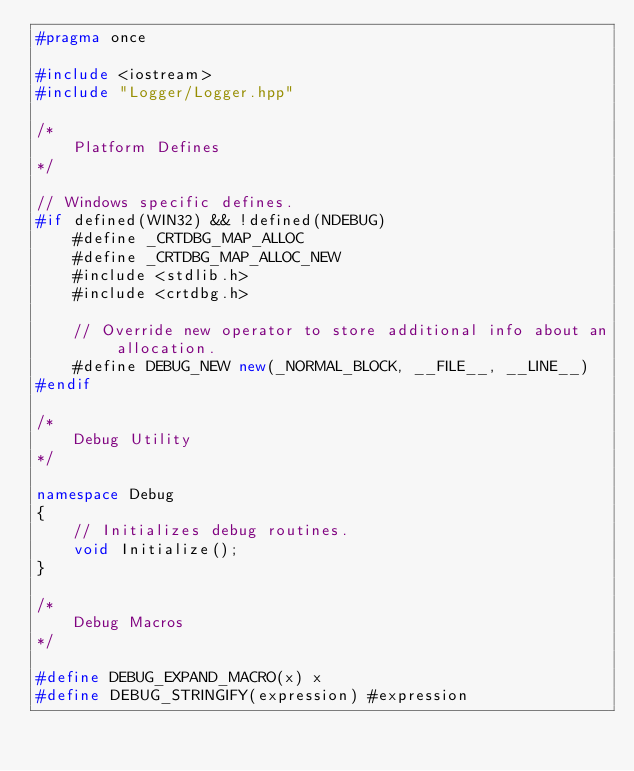Convert code to text. <code><loc_0><loc_0><loc_500><loc_500><_C++_>#pragma once

#include <iostream>
#include "Logger/Logger.hpp"

/*
    Platform Defines
*/

// Windows specific defines.
#if defined(WIN32) && !defined(NDEBUG)
    #define _CRTDBG_MAP_ALLOC
    #define _CRTDBG_MAP_ALLOC_NEW
    #include <stdlib.h>
    #include <crtdbg.h>

    // Override new operator to store additional info about an allocation.
    #define DEBUG_NEW new(_NORMAL_BLOCK, __FILE__, __LINE__)
#endif

/*
    Debug Utility
*/

namespace Debug
{
    // Initializes debug routines.
    void Initialize();
}

/*
    Debug Macros
*/

#define DEBUG_EXPAND_MACRO(x) x
#define DEBUG_STRINGIFY(expression) #expression</code> 